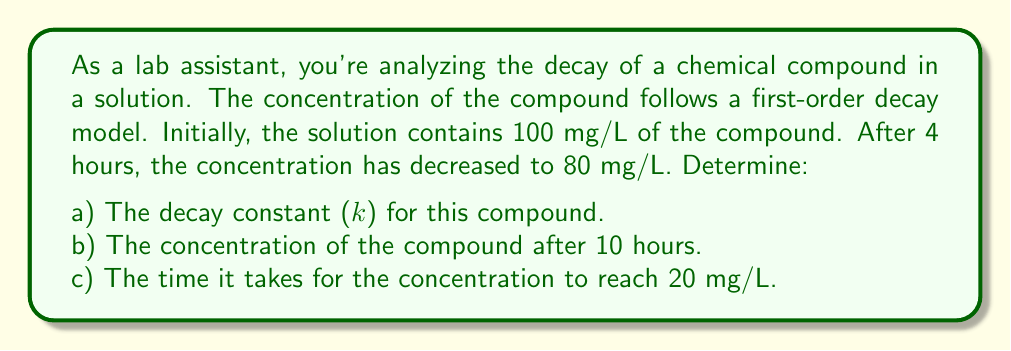Provide a solution to this math problem. Let's approach this problem step-by-step using the first-order decay model:

$$C(t) = C_0 e^{-kt}$$

Where:
$C(t)$ is the concentration at time $t$
$C_0$ is the initial concentration
$k$ is the decay constant
$t$ is time

a) To find the decay constant (k):

We know that $C_0 = 100$ mg/L and after 4 hours, $C(4) = 80$ mg/L.

Substituting into the equation:
$$80 = 100 e^{-4k}$$

Dividing both sides by 100:
$$0.8 = e^{-4k}$$

Taking natural log of both sides:
$$\ln(0.8) = -4k$$

Solving for $k$:
$$k = -\frac{\ln(0.8)}{4} \approx 0.0558 \text{ hour}^{-1}$$

b) To find the concentration after 10 hours:

Using the decay constant we just found and the original equation:

$$C(10) = 100 e^{-0.0558 \cdot 10} \approx 57.31 \text{ mg/L}$$

c) To find the time when concentration reaches 20 mg/L:

We use the equation again, but now we know $C(t) = 20$ and we're solving for $t$:

$$20 = 100 e^{-0.0558t}$$

Dividing both sides by 100:
$$0.2 = e^{-0.0558t}$$

Taking natural log of both sides:
$$\ln(0.2) = -0.0558t$$

Solving for $t$:
$$t = -\frac{\ln(0.2)}{0.0558} \approx 28.86 \text{ hours}$$
Answer: a) The decay constant (k) is approximately 0.0558 hour^(-1).
b) The concentration after 10 hours is approximately 57.31 mg/L.
c) It takes approximately 28.86 hours for the concentration to reach 20 mg/L. 